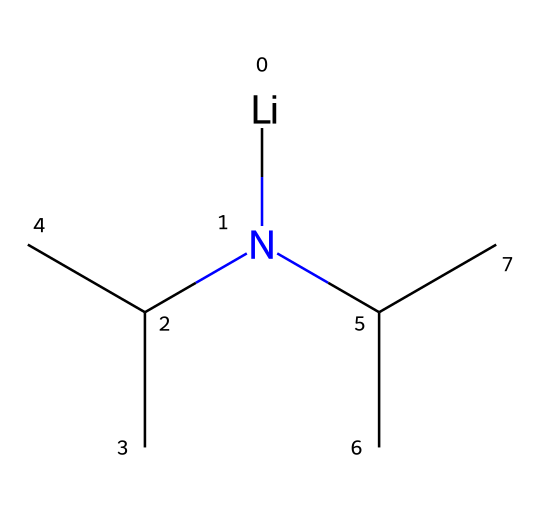What is the molecular formula of lithium diisopropylamide? From the SMILES representation, we can determine the components: there is one lithium atom (Li) and the nitrogen atom (N) attached to two diisopropyl groups (C(C)C). Counting the carbon and hydrogen atoms, we find there are 6 carbons and 13 hydrogens, leading us to the molecular formula.
Answer: C6H13LiN How many nitrogen atoms are present in the structure? The SMILES notation shows the presence of one nitrogen atom (N), which is clearly indicated without any parentheses or additional branching.
Answer: 1 What type of base is LDA classified as? LDA is specifically categorized as a strong non-nucleophilic base, which is made evident by its structure featuring a nitrogen atom bonded to alkyl groups that minimize nucleophilicity.
Answer: non-nucleophilic How is the lithium atom coordinated in lithium diisopropylamide? The lithium atom is directly bonded to the nitrogen atom, indicating it acts as a counterion to stabilize the negatively charged amide. This coordination is typical for lithium compounds, allowing for effective deprotonation.
Answer: bonded to nitrogen Which groups contribute to the steric bulk in LDA? The diisopropyl groups (C(C)C) provide significant steric hindrance around the nitrogen atom, making LDA a hindered base. This can be inferred from the presence of two branched isopropyl groups connected to the nitrogen.
Answer: diisopropyl groups 